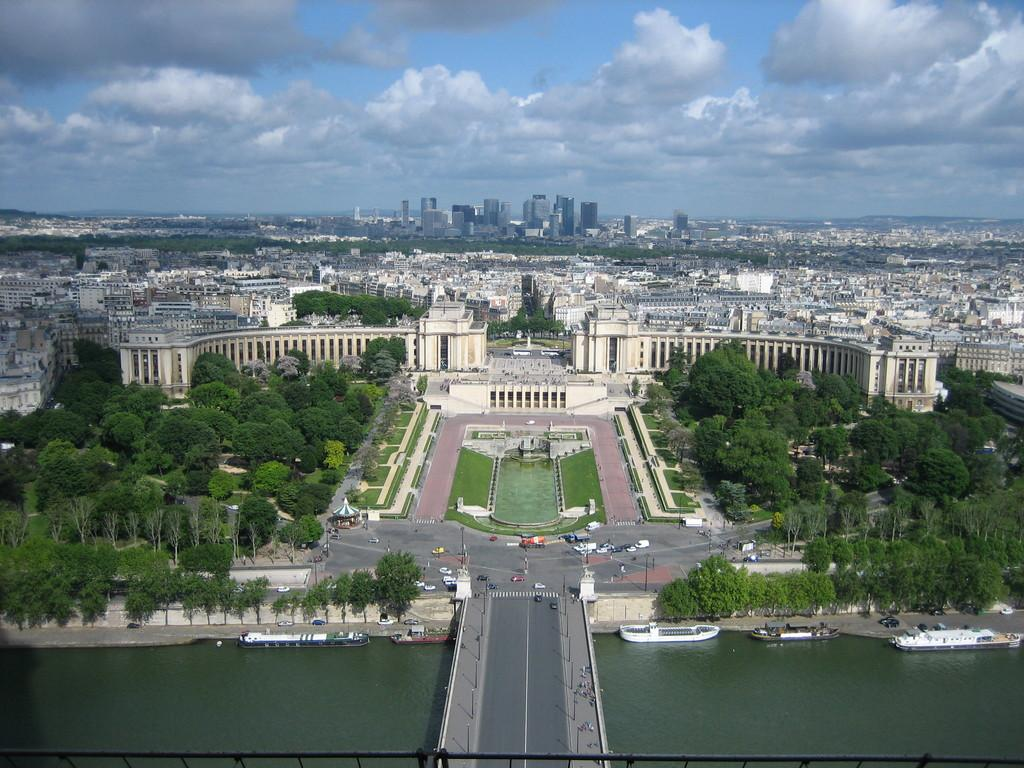What type of natural elements can be seen in the image? There are trees in the image. What type of man-made structures are present in the image? There are buildings in the image. What type of transportation is visible in the image? There are boats on the water surface in the image. What type of architectural feature is present in the image? There is a bridge in the image. What is visible in the sky in the image? Clouds are visible in the sky in the image. Can you see any ghosts in the image? There are no ghosts present in the image. What type of window is visible in the image? There is no window present in the image. 